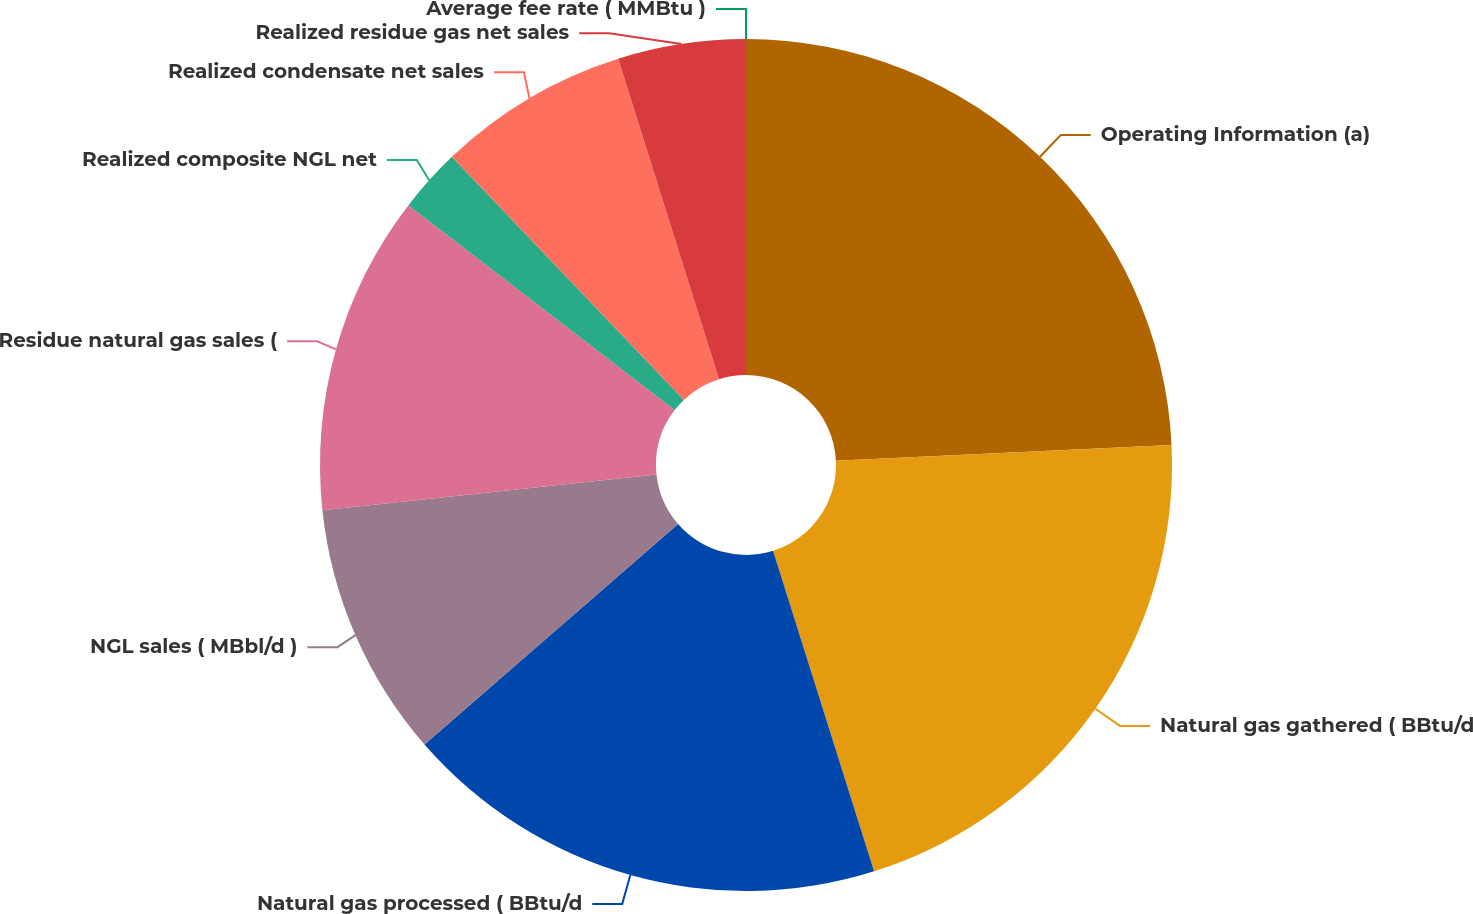<chart> <loc_0><loc_0><loc_500><loc_500><pie_chart><fcel>Operating Information (a)<fcel>Natural gas gathered ( BBtu/d<fcel>Natural gas processed ( BBtu/d<fcel>NGL sales ( MBbl/d )<fcel>Residue natural gas sales (<fcel>Realized composite NGL net<fcel>Realized condensate net sales<fcel>Realized residue gas net sales<fcel>Average fee rate ( MMBtu )<nl><fcel>24.25%<fcel>20.89%<fcel>18.47%<fcel>9.7%<fcel>12.13%<fcel>2.43%<fcel>7.28%<fcel>4.85%<fcel>0.0%<nl></chart> 